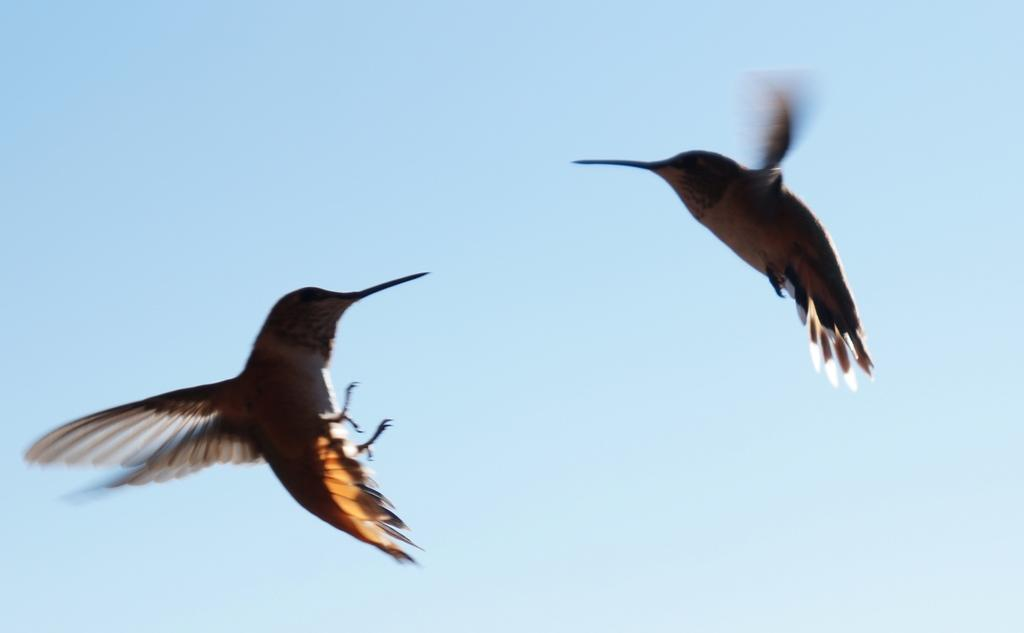How many birds are visible in the image? There are two birds in the image. What are the birds doing in the image? The birds are flying in the air. What color is the stranger's silver car in the image? There is no stranger or car present in the image; it only features two birds flying in the air. 